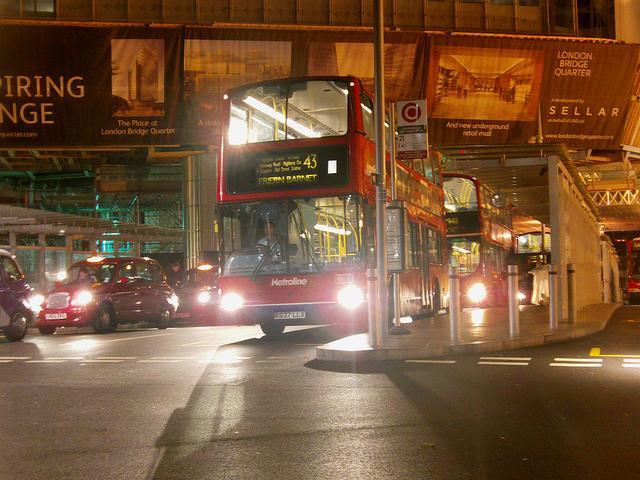Is the bus in service?
Quick response, please. Yes. Is the bus too tall for the underpass?
Keep it brief. No. What number is on the bus?
Be succinct. 43. 